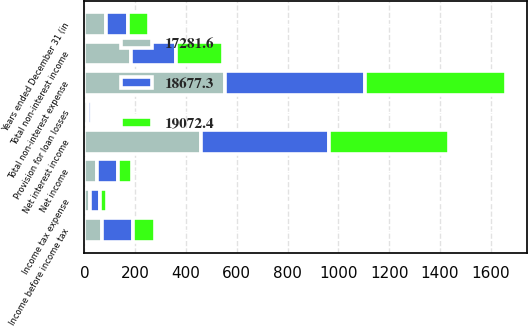<chart> <loc_0><loc_0><loc_500><loc_500><stacked_bar_chart><ecel><fcel>Years ended December 31 (in<fcel>Net interest income<fcel>Provision for loan losses<fcel>Total non-interest income<fcel>Total non-interest expense<fcel>Income before income tax<fcel>Income tax expense<fcel>Net income<nl><fcel>17281.6<fcel>85.1<fcel>459.6<fcel>15.4<fcel>181.6<fcel>554.8<fcel>71<fcel>22.5<fcel>48.5<nl><fcel>18677.3<fcel>85.1<fcel>504<fcel>14<fcel>179.5<fcel>548.3<fcel>121.2<fcel>39.4<fcel>81.8<nl><fcel>19072.4<fcel>85.1<fcel>469.7<fcel>10.9<fcel>184.4<fcel>558.1<fcel>85.1<fcel>27.8<fcel>57.3<nl></chart> 